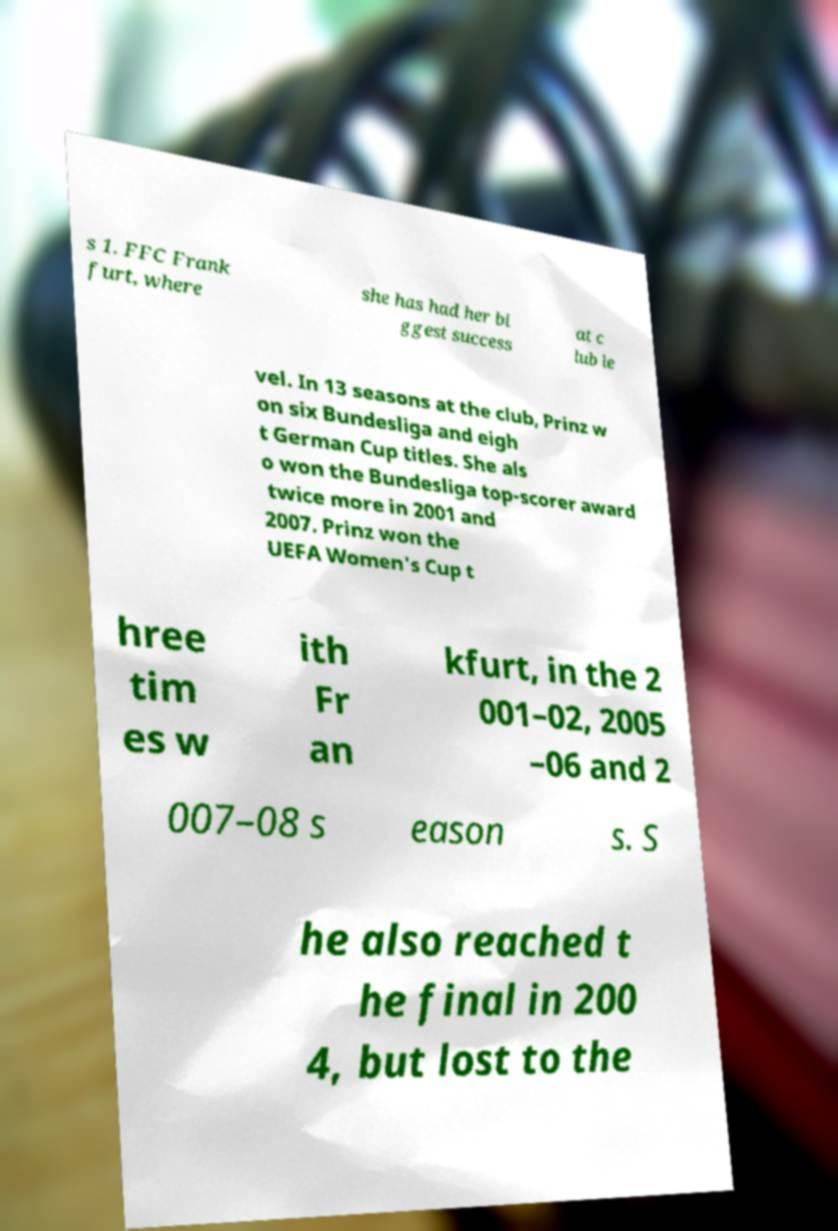Could you extract and type out the text from this image? s 1. FFC Frank furt, where she has had her bi ggest success at c lub le vel. In 13 seasons at the club, Prinz w on six Bundesliga and eigh t German Cup titles. She als o won the Bundesliga top-scorer award twice more in 2001 and 2007. Prinz won the UEFA Women's Cup t hree tim es w ith Fr an kfurt, in the 2 001–02, 2005 –06 and 2 007–08 s eason s. S he also reached t he final in 200 4, but lost to the 